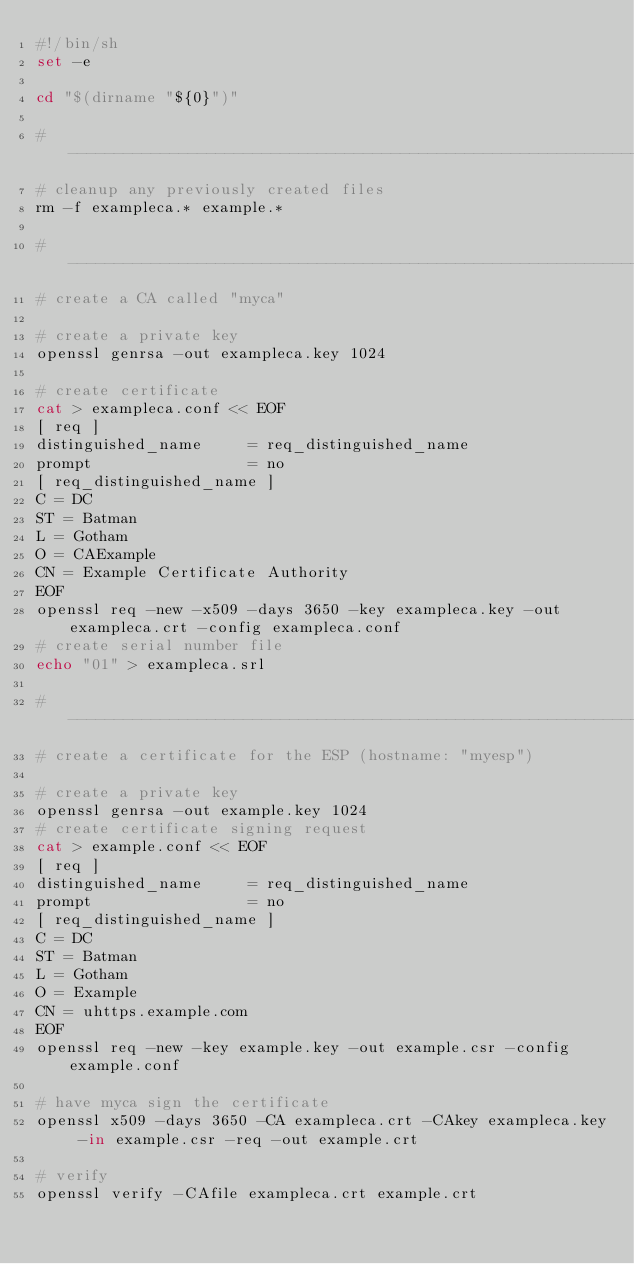<code> <loc_0><loc_0><loc_500><loc_500><_Bash_>#!/bin/sh
set -e

cd "$(dirname "${0}")"

#------------------------------------------------------------------------------
# cleanup any previously created files
rm -f exampleca.* example.*

#------------------------------------------------------------------------------
# create a CA called "myca"

# create a private key
openssl genrsa -out exampleca.key 1024

# create certificate
cat > exampleca.conf << EOF
[ req ]
distinguished_name     = req_distinguished_name
prompt                 = no
[ req_distinguished_name ]
C = DC
ST = Batman
L = Gotham
O = CAExample
CN = Example Certificate Authority
EOF
openssl req -new -x509 -days 3650 -key exampleca.key -out exampleca.crt -config exampleca.conf
# create serial number file
echo "01" > exampleca.srl

#------------------------------------------------------------------------------
# create a certificate for the ESP (hostname: "myesp")

# create a private key
openssl genrsa -out example.key 1024
# create certificate signing request
cat > example.conf << EOF
[ req ]
distinguished_name     = req_distinguished_name
prompt                 = no
[ req_distinguished_name ]
C = DC
ST = Batman
L = Gotham
O = Example
CN = uhttps.example.com
EOF
openssl req -new -key example.key -out example.csr -config example.conf

# have myca sign the certificate
openssl x509 -days 3650 -CA exampleca.crt -CAkey exampleca.key -in example.csr -req -out example.crt

# verify
openssl verify -CAfile exampleca.crt example.crt
</code> 